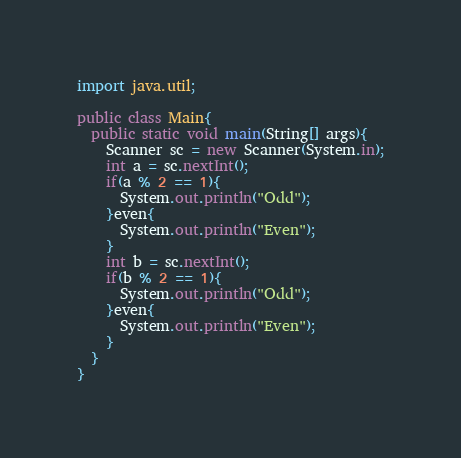Convert code to text. <code><loc_0><loc_0><loc_500><loc_500><_Java_>import java.util;

public class Main{
  public static void main(String[] args){
    Scanner sc = new Scanner(System.in);
    int a = sc.nextInt();
    if(a % 2 == 1){
      System.out.println("Odd");
    }even{
      System.out.println("Even");
    }
    int b = sc.nextInt();
    if(b % 2 == 1){
      System.out.println("Odd");
    }even{
      System.out.println("Even");
    }
  }
}</code> 